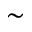Convert formula to latex. <formula><loc_0><loc_0><loc_500><loc_500>\sim</formula> 